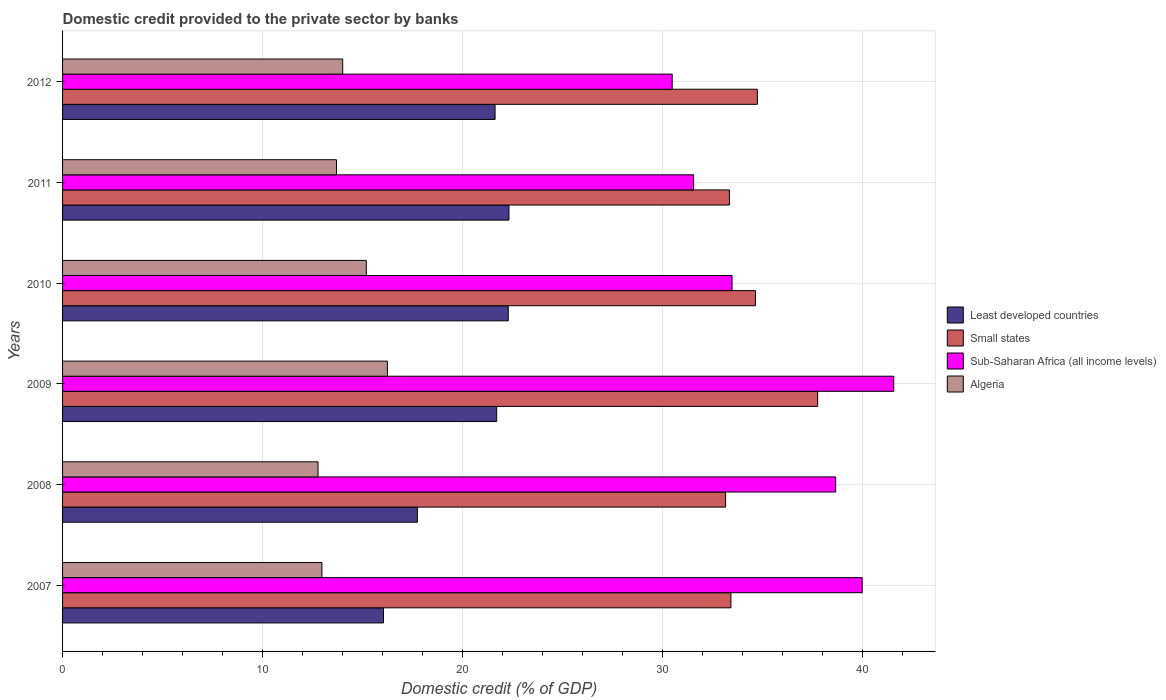How many groups of bars are there?
Offer a terse response. 6. Are the number of bars per tick equal to the number of legend labels?
Give a very brief answer. Yes. How many bars are there on the 6th tick from the top?
Make the answer very short. 4. How many bars are there on the 2nd tick from the bottom?
Keep it short and to the point. 4. In how many cases, is the number of bars for a given year not equal to the number of legend labels?
Provide a succinct answer. 0. What is the domestic credit provided to the private sector by banks in Small states in 2008?
Offer a terse response. 33.16. Across all years, what is the maximum domestic credit provided to the private sector by banks in Algeria?
Ensure brevity in your answer.  16.25. Across all years, what is the minimum domestic credit provided to the private sector by banks in Algeria?
Offer a terse response. 12.78. In which year was the domestic credit provided to the private sector by banks in Small states minimum?
Make the answer very short. 2008. What is the total domestic credit provided to the private sector by banks in Small states in the graph?
Keep it short and to the point. 207.1. What is the difference between the domestic credit provided to the private sector by banks in Sub-Saharan Africa (all income levels) in 2007 and that in 2008?
Provide a succinct answer. 1.32. What is the difference between the domestic credit provided to the private sector by banks in Algeria in 2011 and the domestic credit provided to the private sector by banks in Sub-Saharan Africa (all income levels) in 2007?
Make the answer very short. -26.29. What is the average domestic credit provided to the private sector by banks in Small states per year?
Offer a very short reply. 34.52. In the year 2011, what is the difference between the domestic credit provided to the private sector by banks in Algeria and domestic credit provided to the private sector by banks in Small states?
Provide a succinct answer. -19.65. What is the ratio of the domestic credit provided to the private sector by banks in Sub-Saharan Africa (all income levels) in 2009 to that in 2012?
Your response must be concise. 1.36. Is the domestic credit provided to the private sector by banks in Algeria in 2007 less than that in 2009?
Your response must be concise. Yes. Is the difference between the domestic credit provided to the private sector by banks in Algeria in 2008 and 2011 greater than the difference between the domestic credit provided to the private sector by banks in Small states in 2008 and 2011?
Provide a short and direct response. No. What is the difference between the highest and the second highest domestic credit provided to the private sector by banks in Least developed countries?
Ensure brevity in your answer.  0.03. What is the difference between the highest and the lowest domestic credit provided to the private sector by banks in Sub-Saharan Africa (all income levels)?
Your answer should be compact. 11.08. Is the sum of the domestic credit provided to the private sector by banks in Algeria in 2007 and 2010 greater than the maximum domestic credit provided to the private sector by banks in Sub-Saharan Africa (all income levels) across all years?
Keep it short and to the point. No. What does the 4th bar from the top in 2012 represents?
Offer a terse response. Least developed countries. What does the 1st bar from the bottom in 2009 represents?
Provide a short and direct response. Least developed countries. Is it the case that in every year, the sum of the domestic credit provided to the private sector by banks in Sub-Saharan Africa (all income levels) and domestic credit provided to the private sector by banks in Least developed countries is greater than the domestic credit provided to the private sector by banks in Small states?
Offer a very short reply. Yes. How many bars are there?
Offer a terse response. 24. Are all the bars in the graph horizontal?
Your response must be concise. Yes. How many years are there in the graph?
Your answer should be very brief. 6. Are the values on the major ticks of X-axis written in scientific E-notation?
Offer a terse response. No. Where does the legend appear in the graph?
Your answer should be very brief. Center right. What is the title of the graph?
Your answer should be compact. Domestic credit provided to the private sector by banks. What is the label or title of the X-axis?
Provide a succinct answer. Domestic credit (% of GDP). What is the Domestic credit (% of GDP) of Least developed countries in 2007?
Provide a succinct answer. 16.05. What is the Domestic credit (% of GDP) in Small states in 2007?
Give a very brief answer. 33.43. What is the Domestic credit (% of GDP) in Sub-Saharan Africa (all income levels) in 2007?
Ensure brevity in your answer.  39.99. What is the Domestic credit (% of GDP) in Algeria in 2007?
Your answer should be very brief. 12.97. What is the Domestic credit (% of GDP) in Least developed countries in 2008?
Your answer should be compact. 17.75. What is the Domestic credit (% of GDP) of Small states in 2008?
Your answer should be compact. 33.16. What is the Domestic credit (% of GDP) in Sub-Saharan Africa (all income levels) in 2008?
Offer a very short reply. 38.66. What is the Domestic credit (% of GDP) of Algeria in 2008?
Provide a short and direct response. 12.78. What is the Domestic credit (% of GDP) in Least developed countries in 2009?
Ensure brevity in your answer.  21.71. What is the Domestic credit (% of GDP) of Small states in 2009?
Give a very brief answer. 37.76. What is the Domestic credit (% of GDP) in Sub-Saharan Africa (all income levels) in 2009?
Offer a very short reply. 41.57. What is the Domestic credit (% of GDP) of Algeria in 2009?
Make the answer very short. 16.25. What is the Domestic credit (% of GDP) in Least developed countries in 2010?
Keep it short and to the point. 22.29. What is the Domestic credit (% of GDP) in Small states in 2010?
Provide a succinct answer. 34.65. What is the Domestic credit (% of GDP) in Sub-Saharan Africa (all income levels) in 2010?
Give a very brief answer. 33.48. What is the Domestic credit (% of GDP) of Algeria in 2010?
Offer a very short reply. 15.19. What is the Domestic credit (% of GDP) of Least developed countries in 2011?
Your answer should be very brief. 22.32. What is the Domestic credit (% of GDP) in Small states in 2011?
Give a very brief answer. 33.35. What is the Domestic credit (% of GDP) of Sub-Saharan Africa (all income levels) in 2011?
Provide a short and direct response. 31.56. What is the Domestic credit (% of GDP) of Algeria in 2011?
Your answer should be very brief. 13.7. What is the Domestic credit (% of GDP) in Least developed countries in 2012?
Make the answer very short. 21.63. What is the Domestic credit (% of GDP) of Small states in 2012?
Ensure brevity in your answer.  34.75. What is the Domestic credit (% of GDP) of Sub-Saharan Africa (all income levels) in 2012?
Provide a succinct answer. 30.49. What is the Domestic credit (% of GDP) of Algeria in 2012?
Provide a short and direct response. 14.01. Across all years, what is the maximum Domestic credit (% of GDP) of Least developed countries?
Offer a terse response. 22.32. Across all years, what is the maximum Domestic credit (% of GDP) in Small states?
Your answer should be compact. 37.76. Across all years, what is the maximum Domestic credit (% of GDP) of Sub-Saharan Africa (all income levels)?
Provide a short and direct response. 41.57. Across all years, what is the maximum Domestic credit (% of GDP) in Algeria?
Keep it short and to the point. 16.25. Across all years, what is the minimum Domestic credit (% of GDP) in Least developed countries?
Provide a succinct answer. 16.05. Across all years, what is the minimum Domestic credit (% of GDP) of Small states?
Provide a short and direct response. 33.16. Across all years, what is the minimum Domestic credit (% of GDP) in Sub-Saharan Africa (all income levels)?
Give a very brief answer. 30.49. Across all years, what is the minimum Domestic credit (% of GDP) in Algeria?
Your answer should be compact. 12.78. What is the total Domestic credit (% of GDP) of Least developed countries in the graph?
Ensure brevity in your answer.  121.75. What is the total Domestic credit (% of GDP) in Small states in the graph?
Provide a short and direct response. 207.1. What is the total Domestic credit (% of GDP) of Sub-Saharan Africa (all income levels) in the graph?
Provide a succinct answer. 215.75. What is the total Domestic credit (% of GDP) of Algeria in the graph?
Make the answer very short. 84.89. What is the difference between the Domestic credit (% of GDP) in Least developed countries in 2007 and that in 2008?
Your answer should be compact. -1.7. What is the difference between the Domestic credit (% of GDP) in Small states in 2007 and that in 2008?
Offer a very short reply. 0.27. What is the difference between the Domestic credit (% of GDP) in Sub-Saharan Africa (all income levels) in 2007 and that in 2008?
Ensure brevity in your answer.  1.32. What is the difference between the Domestic credit (% of GDP) of Algeria in 2007 and that in 2008?
Ensure brevity in your answer.  0.19. What is the difference between the Domestic credit (% of GDP) of Least developed countries in 2007 and that in 2009?
Your response must be concise. -5.66. What is the difference between the Domestic credit (% of GDP) of Small states in 2007 and that in 2009?
Provide a succinct answer. -4.34. What is the difference between the Domestic credit (% of GDP) in Sub-Saharan Africa (all income levels) in 2007 and that in 2009?
Your response must be concise. -1.58. What is the difference between the Domestic credit (% of GDP) of Algeria in 2007 and that in 2009?
Provide a succinct answer. -3.28. What is the difference between the Domestic credit (% of GDP) in Least developed countries in 2007 and that in 2010?
Give a very brief answer. -6.24. What is the difference between the Domestic credit (% of GDP) in Small states in 2007 and that in 2010?
Offer a terse response. -1.23. What is the difference between the Domestic credit (% of GDP) in Sub-Saharan Africa (all income levels) in 2007 and that in 2010?
Your answer should be compact. 6.51. What is the difference between the Domestic credit (% of GDP) of Algeria in 2007 and that in 2010?
Make the answer very short. -2.22. What is the difference between the Domestic credit (% of GDP) of Least developed countries in 2007 and that in 2011?
Give a very brief answer. -6.27. What is the difference between the Domestic credit (% of GDP) of Small states in 2007 and that in 2011?
Provide a succinct answer. 0.08. What is the difference between the Domestic credit (% of GDP) in Sub-Saharan Africa (all income levels) in 2007 and that in 2011?
Offer a very short reply. 8.43. What is the difference between the Domestic credit (% of GDP) of Algeria in 2007 and that in 2011?
Give a very brief answer. -0.73. What is the difference between the Domestic credit (% of GDP) in Least developed countries in 2007 and that in 2012?
Offer a terse response. -5.58. What is the difference between the Domestic credit (% of GDP) of Small states in 2007 and that in 2012?
Ensure brevity in your answer.  -1.32. What is the difference between the Domestic credit (% of GDP) in Sub-Saharan Africa (all income levels) in 2007 and that in 2012?
Provide a short and direct response. 9.5. What is the difference between the Domestic credit (% of GDP) of Algeria in 2007 and that in 2012?
Your answer should be compact. -1.04. What is the difference between the Domestic credit (% of GDP) in Least developed countries in 2008 and that in 2009?
Your answer should be very brief. -3.96. What is the difference between the Domestic credit (% of GDP) of Small states in 2008 and that in 2009?
Your response must be concise. -4.6. What is the difference between the Domestic credit (% of GDP) of Sub-Saharan Africa (all income levels) in 2008 and that in 2009?
Offer a very short reply. -2.9. What is the difference between the Domestic credit (% of GDP) in Algeria in 2008 and that in 2009?
Offer a terse response. -3.47. What is the difference between the Domestic credit (% of GDP) in Least developed countries in 2008 and that in 2010?
Give a very brief answer. -4.54. What is the difference between the Domestic credit (% of GDP) of Small states in 2008 and that in 2010?
Your answer should be very brief. -1.49. What is the difference between the Domestic credit (% of GDP) in Sub-Saharan Africa (all income levels) in 2008 and that in 2010?
Make the answer very short. 5.18. What is the difference between the Domestic credit (% of GDP) of Algeria in 2008 and that in 2010?
Provide a succinct answer. -2.41. What is the difference between the Domestic credit (% of GDP) in Least developed countries in 2008 and that in 2011?
Keep it short and to the point. -4.58. What is the difference between the Domestic credit (% of GDP) in Small states in 2008 and that in 2011?
Make the answer very short. -0.19. What is the difference between the Domestic credit (% of GDP) in Sub-Saharan Africa (all income levels) in 2008 and that in 2011?
Provide a short and direct response. 7.11. What is the difference between the Domestic credit (% of GDP) in Algeria in 2008 and that in 2011?
Provide a succinct answer. -0.92. What is the difference between the Domestic credit (% of GDP) in Least developed countries in 2008 and that in 2012?
Offer a terse response. -3.88. What is the difference between the Domestic credit (% of GDP) in Small states in 2008 and that in 2012?
Provide a succinct answer. -1.59. What is the difference between the Domestic credit (% of GDP) of Sub-Saharan Africa (all income levels) in 2008 and that in 2012?
Offer a very short reply. 8.18. What is the difference between the Domestic credit (% of GDP) in Algeria in 2008 and that in 2012?
Your answer should be very brief. -1.23. What is the difference between the Domestic credit (% of GDP) of Least developed countries in 2009 and that in 2010?
Give a very brief answer. -0.58. What is the difference between the Domestic credit (% of GDP) of Small states in 2009 and that in 2010?
Offer a very short reply. 3.11. What is the difference between the Domestic credit (% of GDP) of Sub-Saharan Africa (all income levels) in 2009 and that in 2010?
Ensure brevity in your answer.  8.09. What is the difference between the Domestic credit (% of GDP) of Algeria in 2009 and that in 2010?
Your response must be concise. 1.05. What is the difference between the Domestic credit (% of GDP) in Least developed countries in 2009 and that in 2011?
Keep it short and to the point. -0.61. What is the difference between the Domestic credit (% of GDP) in Small states in 2009 and that in 2011?
Make the answer very short. 4.41. What is the difference between the Domestic credit (% of GDP) in Sub-Saharan Africa (all income levels) in 2009 and that in 2011?
Offer a very short reply. 10.01. What is the difference between the Domestic credit (% of GDP) of Algeria in 2009 and that in 2011?
Give a very brief answer. 2.55. What is the difference between the Domestic credit (% of GDP) of Least developed countries in 2009 and that in 2012?
Keep it short and to the point. 0.08. What is the difference between the Domestic credit (% of GDP) in Small states in 2009 and that in 2012?
Ensure brevity in your answer.  3.01. What is the difference between the Domestic credit (% of GDP) in Sub-Saharan Africa (all income levels) in 2009 and that in 2012?
Offer a terse response. 11.08. What is the difference between the Domestic credit (% of GDP) in Algeria in 2009 and that in 2012?
Your answer should be very brief. 2.24. What is the difference between the Domestic credit (% of GDP) of Least developed countries in 2010 and that in 2011?
Offer a very short reply. -0.03. What is the difference between the Domestic credit (% of GDP) in Small states in 2010 and that in 2011?
Your answer should be compact. 1.3. What is the difference between the Domestic credit (% of GDP) in Sub-Saharan Africa (all income levels) in 2010 and that in 2011?
Your answer should be very brief. 1.92. What is the difference between the Domestic credit (% of GDP) in Algeria in 2010 and that in 2011?
Keep it short and to the point. 1.49. What is the difference between the Domestic credit (% of GDP) of Least developed countries in 2010 and that in 2012?
Make the answer very short. 0.66. What is the difference between the Domestic credit (% of GDP) of Small states in 2010 and that in 2012?
Provide a short and direct response. -0.1. What is the difference between the Domestic credit (% of GDP) of Sub-Saharan Africa (all income levels) in 2010 and that in 2012?
Make the answer very short. 2.99. What is the difference between the Domestic credit (% of GDP) of Algeria in 2010 and that in 2012?
Provide a succinct answer. 1.18. What is the difference between the Domestic credit (% of GDP) of Least developed countries in 2011 and that in 2012?
Your response must be concise. 0.69. What is the difference between the Domestic credit (% of GDP) of Small states in 2011 and that in 2012?
Your answer should be compact. -1.4. What is the difference between the Domestic credit (% of GDP) of Sub-Saharan Africa (all income levels) in 2011 and that in 2012?
Make the answer very short. 1.07. What is the difference between the Domestic credit (% of GDP) in Algeria in 2011 and that in 2012?
Provide a succinct answer. -0.31. What is the difference between the Domestic credit (% of GDP) of Least developed countries in 2007 and the Domestic credit (% of GDP) of Small states in 2008?
Keep it short and to the point. -17.11. What is the difference between the Domestic credit (% of GDP) in Least developed countries in 2007 and the Domestic credit (% of GDP) in Sub-Saharan Africa (all income levels) in 2008?
Offer a very short reply. -22.61. What is the difference between the Domestic credit (% of GDP) of Least developed countries in 2007 and the Domestic credit (% of GDP) of Algeria in 2008?
Keep it short and to the point. 3.27. What is the difference between the Domestic credit (% of GDP) in Small states in 2007 and the Domestic credit (% of GDP) in Sub-Saharan Africa (all income levels) in 2008?
Provide a short and direct response. -5.24. What is the difference between the Domestic credit (% of GDP) of Small states in 2007 and the Domestic credit (% of GDP) of Algeria in 2008?
Your answer should be very brief. 20.65. What is the difference between the Domestic credit (% of GDP) in Sub-Saharan Africa (all income levels) in 2007 and the Domestic credit (% of GDP) in Algeria in 2008?
Your response must be concise. 27.21. What is the difference between the Domestic credit (% of GDP) in Least developed countries in 2007 and the Domestic credit (% of GDP) in Small states in 2009?
Your answer should be very brief. -21.71. What is the difference between the Domestic credit (% of GDP) in Least developed countries in 2007 and the Domestic credit (% of GDP) in Sub-Saharan Africa (all income levels) in 2009?
Make the answer very short. -25.52. What is the difference between the Domestic credit (% of GDP) in Least developed countries in 2007 and the Domestic credit (% of GDP) in Algeria in 2009?
Offer a terse response. -0.19. What is the difference between the Domestic credit (% of GDP) of Small states in 2007 and the Domestic credit (% of GDP) of Sub-Saharan Africa (all income levels) in 2009?
Provide a short and direct response. -8.14. What is the difference between the Domestic credit (% of GDP) in Small states in 2007 and the Domestic credit (% of GDP) in Algeria in 2009?
Keep it short and to the point. 17.18. What is the difference between the Domestic credit (% of GDP) in Sub-Saharan Africa (all income levels) in 2007 and the Domestic credit (% of GDP) in Algeria in 2009?
Offer a very short reply. 23.74. What is the difference between the Domestic credit (% of GDP) of Least developed countries in 2007 and the Domestic credit (% of GDP) of Small states in 2010?
Provide a short and direct response. -18.6. What is the difference between the Domestic credit (% of GDP) of Least developed countries in 2007 and the Domestic credit (% of GDP) of Sub-Saharan Africa (all income levels) in 2010?
Give a very brief answer. -17.43. What is the difference between the Domestic credit (% of GDP) of Least developed countries in 2007 and the Domestic credit (% of GDP) of Algeria in 2010?
Ensure brevity in your answer.  0.86. What is the difference between the Domestic credit (% of GDP) of Small states in 2007 and the Domestic credit (% of GDP) of Sub-Saharan Africa (all income levels) in 2010?
Offer a very short reply. -0.06. What is the difference between the Domestic credit (% of GDP) in Small states in 2007 and the Domestic credit (% of GDP) in Algeria in 2010?
Give a very brief answer. 18.24. What is the difference between the Domestic credit (% of GDP) in Sub-Saharan Africa (all income levels) in 2007 and the Domestic credit (% of GDP) in Algeria in 2010?
Offer a very short reply. 24.8. What is the difference between the Domestic credit (% of GDP) in Least developed countries in 2007 and the Domestic credit (% of GDP) in Small states in 2011?
Ensure brevity in your answer.  -17.3. What is the difference between the Domestic credit (% of GDP) of Least developed countries in 2007 and the Domestic credit (% of GDP) of Sub-Saharan Africa (all income levels) in 2011?
Your answer should be compact. -15.51. What is the difference between the Domestic credit (% of GDP) of Least developed countries in 2007 and the Domestic credit (% of GDP) of Algeria in 2011?
Offer a terse response. 2.35. What is the difference between the Domestic credit (% of GDP) in Small states in 2007 and the Domestic credit (% of GDP) in Sub-Saharan Africa (all income levels) in 2011?
Make the answer very short. 1.87. What is the difference between the Domestic credit (% of GDP) of Small states in 2007 and the Domestic credit (% of GDP) of Algeria in 2011?
Make the answer very short. 19.73. What is the difference between the Domestic credit (% of GDP) in Sub-Saharan Africa (all income levels) in 2007 and the Domestic credit (% of GDP) in Algeria in 2011?
Give a very brief answer. 26.29. What is the difference between the Domestic credit (% of GDP) in Least developed countries in 2007 and the Domestic credit (% of GDP) in Small states in 2012?
Make the answer very short. -18.7. What is the difference between the Domestic credit (% of GDP) in Least developed countries in 2007 and the Domestic credit (% of GDP) in Sub-Saharan Africa (all income levels) in 2012?
Provide a succinct answer. -14.44. What is the difference between the Domestic credit (% of GDP) in Least developed countries in 2007 and the Domestic credit (% of GDP) in Algeria in 2012?
Offer a terse response. 2.04. What is the difference between the Domestic credit (% of GDP) of Small states in 2007 and the Domestic credit (% of GDP) of Sub-Saharan Africa (all income levels) in 2012?
Keep it short and to the point. 2.94. What is the difference between the Domestic credit (% of GDP) in Small states in 2007 and the Domestic credit (% of GDP) in Algeria in 2012?
Your answer should be compact. 19.42. What is the difference between the Domestic credit (% of GDP) in Sub-Saharan Africa (all income levels) in 2007 and the Domestic credit (% of GDP) in Algeria in 2012?
Provide a short and direct response. 25.98. What is the difference between the Domestic credit (% of GDP) of Least developed countries in 2008 and the Domestic credit (% of GDP) of Small states in 2009?
Ensure brevity in your answer.  -20.02. What is the difference between the Domestic credit (% of GDP) in Least developed countries in 2008 and the Domestic credit (% of GDP) in Sub-Saharan Africa (all income levels) in 2009?
Your answer should be very brief. -23.82. What is the difference between the Domestic credit (% of GDP) in Least developed countries in 2008 and the Domestic credit (% of GDP) in Algeria in 2009?
Make the answer very short. 1.5. What is the difference between the Domestic credit (% of GDP) in Small states in 2008 and the Domestic credit (% of GDP) in Sub-Saharan Africa (all income levels) in 2009?
Offer a terse response. -8.41. What is the difference between the Domestic credit (% of GDP) in Small states in 2008 and the Domestic credit (% of GDP) in Algeria in 2009?
Give a very brief answer. 16.91. What is the difference between the Domestic credit (% of GDP) of Sub-Saharan Africa (all income levels) in 2008 and the Domestic credit (% of GDP) of Algeria in 2009?
Make the answer very short. 22.42. What is the difference between the Domestic credit (% of GDP) in Least developed countries in 2008 and the Domestic credit (% of GDP) in Small states in 2010?
Give a very brief answer. -16.91. What is the difference between the Domestic credit (% of GDP) in Least developed countries in 2008 and the Domestic credit (% of GDP) in Sub-Saharan Africa (all income levels) in 2010?
Provide a succinct answer. -15.74. What is the difference between the Domestic credit (% of GDP) in Least developed countries in 2008 and the Domestic credit (% of GDP) in Algeria in 2010?
Give a very brief answer. 2.55. What is the difference between the Domestic credit (% of GDP) in Small states in 2008 and the Domestic credit (% of GDP) in Sub-Saharan Africa (all income levels) in 2010?
Offer a very short reply. -0.32. What is the difference between the Domestic credit (% of GDP) of Small states in 2008 and the Domestic credit (% of GDP) of Algeria in 2010?
Ensure brevity in your answer.  17.97. What is the difference between the Domestic credit (% of GDP) of Sub-Saharan Africa (all income levels) in 2008 and the Domestic credit (% of GDP) of Algeria in 2010?
Ensure brevity in your answer.  23.47. What is the difference between the Domestic credit (% of GDP) of Least developed countries in 2008 and the Domestic credit (% of GDP) of Small states in 2011?
Offer a terse response. -15.6. What is the difference between the Domestic credit (% of GDP) in Least developed countries in 2008 and the Domestic credit (% of GDP) in Sub-Saharan Africa (all income levels) in 2011?
Offer a very short reply. -13.81. What is the difference between the Domestic credit (% of GDP) in Least developed countries in 2008 and the Domestic credit (% of GDP) in Algeria in 2011?
Keep it short and to the point. 4.05. What is the difference between the Domestic credit (% of GDP) of Small states in 2008 and the Domestic credit (% of GDP) of Sub-Saharan Africa (all income levels) in 2011?
Make the answer very short. 1.6. What is the difference between the Domestic credit (% of GDP) in Small states in 2008 and the Domestic credit (% of GDP) in Algeria in 2011?
Offer a very short reply. 19.46. What is the difference between the Domestic credit (% of GDP) of Sub-Saharan Africa (all income levels) in 2008 and the Domestic credit (% of GDP) of Algeria in 2011?
Ensure brevity in your answer.  24.97. What is the difference between the Domestic credit (% of GDP) of Least developed countries in 2008 and the Domestic credit (% of GDP) of Small states in 2012?
Your answer should be very brief. -17. What is the difference between the Domestic credit (% of GDP) in Least developed countries in 2008 and the Domestic credit (% of GDP) in Sub-Saharan Africa (all income levels) in 2012?
Make the answer very short. -12.74. What is the difference between the Domestic credit (% of GDP) of Least developed countries in 2008 and the Domestic credit (% of GDP) of Algeria in 2012?
Your answer should be compact. 3.74. What is the difference between the Domestic credit (% of GDP) of Small states in 2008 and the Domestic credit (% of GDP) of Sub-Saharan Africa (all income levels) in 2012?
Your answer should be very brief. 2.67. What is the difference between the Domestic credit (% of GDP) in Small states in 2008 and the Domestic credit (% of GDP) in Algeria in 2012?
Provide a succinct answer. 19.15. What is the difference between the Domestic credit (% of GDP) of Sub-Saharan Africa (all income levels) in 2008 and the Domestic credit (% of GDP) of Algeria in 2012?
Keep it short and to the point. 24.66. What is the difference between the Domestic credit (% of GDP) of Least developed countries in 2009 and the Domestic credit (% of GDP) of Small states in 2010?
Offer a terse response. -12.94. What is the difference between the Domestic credit (% of GDP) of Least developed countries in 2009 and the Domestic credit (% of GDP) of Sub-Saharan Africa (all income levels) in 2010?
Keep it short and to the point. -11.77. What is the difference between the Domestic credit (% of GDP) of Least developed countries in 2009 and the Domestic credit (% of GDP) of Algeria in 2010?
Your answer should be very brief. 6.52. What is the difference between the Domestic credit (% of GDP) in Small states in 2009 and the Domestic credit (% of GDP) in Sub-Saharan Africa (all income levels) in 2010?
Your response must be concise. 4.28. What is the difference between the Domestic credit (% of GDP) in Small states in 2009 and the Domestic credit (% of GDP) in Algeria in 2010?
Give a very brief answer. 22.57. What is the difference between the Domestic credit (% of GDP) in Sub-Saharan Africa (all income levels) in 2009 and the Domestic credit (% of GDP) in Algeria in 2010?
Give a very brief answer. 26.38. What is the difference between the Domestic credit (% of GDP) in Least developed countries in 2009 and the Domestic credit (% of GDP) in Small states in 2011?
Your answer should be very brief. -11.64. What is the difference between the Domestic credit (% of GDP) in Least developed countries in 2009 and the Domestic credit (% of GDP) in Sub-Saharan Africa (all income levels) in 2011?
Offer a very short reply. -9.85. What is the difference between the Domestic credit (% of GDP) of Least developed countries in 2009 and the Domestic credit (% of GDP) of Algeria in 2011?
Offer a terse response. 8.01. What is the difference between the Domestic credit (% of GDP) in Small states in 2009 and the Domestic credit (% of GDP) in Sub-Saharan Africa (all income levels) in 2011?
Ensure brevity in your answer.  6.2. What is the difference between the Domestic credit (% of GDP) in Small states in 2009 and the Domestic credit (% of GDP) in Algeria in 2011?
Your response must be concise. 24.06. What is the difference between the Domestic credit (% of GDP) in Sub-Saharan Africa (all income levels) in 2009 and the Domestic credit (% of GDP) in Algeria in 2011?
Provide a succinct answer. 27.87. What is the difference between the Domestic credit (% of GDP) in Least developed countries in 2009 and the Domestic credit (% of GDP) in Small states in 2012?
Your response must be concise. -13.04. What is the difference between the Domestic credit (% of GDP) of Least developed countries in 2009 and the Domestic credit (% of GDP) of Sub-Saharan Africa (all income levels) in 2012?
Provide a short and direct response. -8.78. What is the difference between the Domestic credit (% of GDP) of Least developed countries in 2009 and the Domestic credit (% of GDP) of Algeria in 2012?
Provide a succinct answer. 7.7. What is the difference between the Domestic credit (% of GDP) in Small states in 2009 and the Domestic credit (% of GDP) in Sub-Saharan Africa (all income levels) in 2012?
Your answer should be very brief. 7.27. What is the difference between the Domestic credit (% of GDP) in Small states in 2009 and the Domestic credit (% of GDP) in Algeria in 2012?
Your response must be concise. 23.75. What is the difference between the Domestic credit (% of GDP) of Sub-Saharan Africa (all income levels) in 2009 and the Domestic credit (% of GDP) of Algeria in 2012?
Offer a terse response. 27.56. What is the difference between the Domestic credit (% of GDP) of Least developed countries in 2010 and the Domestic credit (% of GDP) of Small states in 2011?
Provide a short and direct response. -11.06. What is the difference between the Domestic credit (% of GDP) in Least developed countries in 2010 and the Domestic credit (% of GDP) in Sub-Saharan Africa (all income levels) in 2011?
Make the answer very short. -9.27. What is the difference between the Domestic credit (% of GDP) of Least developed countries in 2010 and the Domestic credit (% of GDP) of Algeria in 2011?
Give a very brief answer. 8.59. What is the difference between the Domestic credit (% of GDP) in Small states in 2010 and the Domestic credit (% of GDP) in Sub-Saharan Africa (all income levels) in 2011?
Offer a very short reply. 3.09. What is the difference between the Domestic credit (% of GDP) in Small states in 2010 and the Domestic credit (% of GDP) in Algeria in 2011?
Your response must be concise. 20.95. What is the difference between the Domestic credit (% of GDP) of Sub-Saharan Africa (all income levels) in 2010 and the Domestic credit (% of GDP) of Algeria in 2011?
Offer a very short reply. 19.78. What is the difference between the Domestic credit (% of GDP) in Least developed countries in 2010 and the Domestic credit (% of GDP) in Small states in 2012?
Your answer should be very brief. -12.46. What is the difference between the Domestic credit (% of GDP) of Least developed countries in 2010 and the Domestic credit (% of GDP) of Sub-Saharan Africa (all income levels) in 2012?
Your answer should be very brief. -8.2. What is the difference between the Domestic credit (% of GDP) in Least developed countries in 2010 and the Domestic credit (% of GDP) in Algeria in 2012?
Make the answer very short. 8.28. What is the difference between the Domestic credit (% of GDP) in Small states in 2010 and the Domestic credit (% of GDP) in Sub-Saharan Africa (all income levels) in 2012?
Give a very brief answer. 4.16. What is the difference between the Domestic credit (% of GDP) of Small states in 2010 and the Domestic credit (% of GDP) of Algeria in 2012?
Your response must be concise. 20.64. What is the difference between the Domestic credit (% of GDP) in Sub-Saharan Africa (all income levels) in 2010 and the Domestic credit (% of GDP) in Algeria in 2012?
Make the answer very short. 19.47. What is the difference between the Domestic credit (% of GDP) of Least developed countries in 2011 and the Domestic credit (% of GDP) of Small states in 2012?
Provide a short and direct response. -12.42. What is the difference between the Domestic credit (% of GDP) of Least developed countries in 2011 and the Domestic credit (% of GDP) of Sub-Saharan Africa (all income levels) in 2012?
Give a very brief answer. -8.16. What is the difference between the Domestic credit (% of GDP) of Least developed countries in 2011 and the Domestic credit (% of GDP) of Algeria in 2012?
Make the answer very short. 8.31. What is the difference between the Domestic credit (% of GDP) of Small states in 2011 and the Domestic credit (% of GDP) of Sub-Saharan Africa (all income levels) in 2012?
Offer a very short reply. 2.86. What is the difference between the Domestic credit (% of GDP) in Small states in 2011 and the Domestic credit (% of GDP) in Algeria in 2012?
Give a very brief answer. 19.34. What is the difference between the Domestic credit (% of GDP) in Sub-Saharan Africa (all income levels) in 2011 and the Domestic credit (% of GDP) in Algeria in 2012?
Your answer should be very brief. 17.55. What is the average Domestic credit (% of GDP) in Least developed countries per year?
Keep it short and to the point. 20.29. What is the average Domestic credit (% of GDP) of Small states per year?
Ensure brevity in your answer.  34.52. What is the average Domestic credit (% of GDP) of Sub-Saharan Africa (all income levels) per year?
Keep it short and to the point. 35.96. What is the average Domestic credit (% of GDP) in Algeria per year?
Provide a short and direct response. 14.15. In the year 2007, what is the difference between the Domestic credit (% of GDP) in Least developed countries and Domestic credit (% of GDP) in Small states?
Your answer should be compact. -17.38. In the year 2007, what is the difference between the Domestic credit (% of GDP) in Least developed countries and Domestic credit (% of GDP) in Sub-Saharan Africa (all income levels)?
Make the answer very short. -23.94. In the year 2007, what is the difference between the Domestic credit (% of GDP) in Least developed countries and Domestic credit (% of GDP) in Algeria?
Offer a very short reply. 3.08. In the year 2007, what is the difference between the Domestic credit (% of GDP) of Small states and Domestic credit (% of GDP) of Sub-Saharan Africa (all income levels)?
Keep it short and to the point. -6.56. In the year 2007, what is the difference between the Domestic credit (% of GDP) of Small states and Domestic credit (% of GDP) of Algeria?
Provide a short and direct response. 20.46. In the year 2007, what is the difference between the Domestic credit (% of GDP) in Sub-Saharan Africa (all income levels) and Domestic credit (% of GDP) in Algeria?
Give a very brief answer. 27.02. In the year 2008, what is the difference between the Domestic credit (% of GDP) of Least developed countries and Domestic credit (% of GDP) of Small states?
Make the answer very short. -15.41. In the year 2008, what is the difference between the Domestic credit (% of GDP) of Least developed countries and Domestic credit (% of GDP) of Sub-Saharan Africa (all income levels)?
Offer a very short reply. -20.92. In the year 2008, what is the difference between the Domestic credit (% of GDP) of Least developed countries and Domestic credit (% of GDP) of Algeria?
Your answer should be very brief. 4.97. In the year 2008, what is the difference between the Domestic credit (% of GDP) of Small states and Domestic credit (% of GDP) of Sub-Saharan Africa (all income levels)?
Ensure brevity in your answer.  -5.51. In the year 2008, what is the difference between the Domestic credit (% of GDP) in Small states and Domestic credit (% of GDP) in Algeria?
Your answer should be very brief. 20.38. In the year 2008, what is the difference between the Domestic credit (% of GDP) of Sub-Saharan Africa (all income levels) and Domestic credit (% of GDP) of Algeria?
Give a very brief answer. 25.89. In the year 2009, what is the difference between the Domestic credit (% of GDP) in Least developed countries and Domestic credit (% of GDP) in Small states?
Ensure brevity in your answer.  -16.05. In the year 2009, what is the difference between the Domestic credit (% of GDP) in Least developed countries and Domestic credit (% of GDP) in Sub-Saharan Africa (all income levels)?
Offer a very short reply. -19.86. In the year 2009, what is the difference between the Domestic credit (% of GDP) of Least developed countries and Domestic credit (% of GDP) of Algeria?
Your answer should be compact. 5.47. In the year 2009, what is the difference between the Domestic credit (% of GDP) of Small states and Domestic credit (% of GDP) of Sub-Saharan Africa (all income levels)?
Offer a very short reply. -3.81. In the year 2009, what is the difference between the Domestic credit (% of GDP) of Small states and Domestic credit (% of GDP) of Algeria?
Your response must be concise. 21.52. In the year 2009, what is the difference between the Domestic credit (% of GDP) of Sub-Saharan Africa (all income levels) and Domestic credit (% of GDP) of Algeria?
Provide a short and direct response. 25.32. In the year 2010, what is the difference between the Domestic credit (% of GDP) in Least developed countries and Domestic credit (% of GDP) in Small states?
Give a very brief answer. -12.36. In the year 2010, what is the difference between the Domestic credit (% of GDP) in Least developed countries and Domestic credit (% of GDP) in Sub-Saharan Africa (all income levels)?
Offer a terse response. -11.19. In the year 2010, what is the difference between the Domestic credit (% of GDP) in Least developed countries and Domestic credit (% of GDP) in Algeria?
Offer a very short reply. 7.1. In the year 2010, what is the difference between the Domestic credit (% of GDP) of Small states and Domestic credit (% of GDP) of Sub-Saharan Africa (all income levels)?
Your answer should be compact. 1.17. In the year 2010, what is the difference between the Domestic credit (% of GDP) of Small states and Domestic credit (% of GDP) of Algeria?
Make the answer very short. 19.46. In the year 2010, what is the difference between the Domestic credit (% of GDP) in Sub-Saharan Africa (all income levels) and Domestic credit (% of GDP) in Algeria?
Your answer should be compact. 18.29. In the year 2011, what is the difference between the Domestic credit (% of GDP) of Least developed countries and Domestic credit (% of GDP) of Small states?
Ensure brevity in your answer.  -11.02. In the year 2011, what is the difference between the Domestic credit (% of GDP) in Least developed countries and Domestic credit (% of GDP) in Sub-Saharan Africa (all income levels)?
Give a very brief answer. -9.23. In the year 2011, what is the difference between the Domestic credit (% of GDP) of Least developed countries and Domestic credit (% of GDP) of Algeria?
Your response must be concise. 8.63. In the year 2011, what is the difference between the Domestic credit (% of GDP) of Small states and Domestic credit (% of GDP) of Sub-Saharan Africa (all income levels)?
Ensure brevity in your answer.  1.79. In the year 2011, what is the difference between the Domestic credit (% of GDP) of Small states and Domestic credit (% of GDP) of Algeria?
Ensure brevity in your answer.  19.65. In the year 2011, what is the difference between the Domestic credit (% of GDP) in Sub-Saharan Africa (all income levels) and Domestic credit (% of GDP) in Algeria?
Your answer should be compact. 17.86. In the year 2012, what is the difference between the Domestic credit (% of GDP) of Least developed countries and Domestic credit (% of GDP) of Small states?
Make the answer very short. -13.12. In the year 2012, what is the difference between the Domestic credit (% of GDP) of Least developed countries and Domestic credit (% of GDP) of Sub-Saharan Africa (all income levels)?
Your response must be concise. -8.86. In the year 2012, what is the difference between the Domestic credit (% of GDP) in Least developed countries and Domestic credit (% of GDP) in Algeria?
Offer a terse response. 7.62. In the year 2012, what is the difference between the Domestic credit (% of GDP) in Small states and Domestic credit (% of GDP) in Sub-Saharan Africa (all income levels)?
Your answer should be very brief. 4.26. In the year 2012, what is the difference between the Domestic credit (% of GDP) of Small states and Domestic credit (% of GDP) of Algeria?
Offer a terse response. 20.74. In the year 2012, what is the difference between the Domestic credit (% of GDP) in Sub-Saharan Africa (all income levels) and Domestic credit (% of GDP) in Algeria?
Your answer should be very brief. 16.48. What is the ratio of the Domestic credit (% of GDP) of Least developed countries in 2007 to that in 2008?
Your answer should be compact. 0.9. What is the ratio of the Domestic credit (% of GDP) in Small states in 2007 to that in 2008?
Your answer should be very brief. 1.01. What is the ratio of the Domestic credit (% of GDP) in Sub-Saharan Africa (all income levels) in 2007 to that in 2008?
Your response must be concise. 1.03. What is the ratio of the Domestic credit (% of GDP) in Algeria in 2007 to that in 2008?
Give a very brief answer. 1.01. What is the ratio of the Domestic credit (% of GDP) in Least developed countries in 2007 to that in 2009?
Provide a succinct answer. 0.74. What is the ratio of the Domestic credit (% of GDP) in Small states in 2007 to that in 2009?
Offer a very short reply. 0.89. What is the ratio of the Domestic credit (% of GDP) in Sub-Saharan Africa (all income levels) in 2007 to that in 2009?
Provide a short and direct response. 0.96. What is the ratio of the Domestic credit (% of GDP) of Algeria in 2007 to that in 2009?
Provide a short and direct response. 0.8. What is the ratio of the Domestic credit (% of GDP) in Least developed countries in 2007 to that in 2010?
Provide a succinct answer. 0.72. What is the ratio of the Domestic credit (% of GDP) in Small states in 2007 to that in 2010?
Your answer should be very brief. 0.96. What is the ratio of the Domestic credit (% of GDP) of Sub-Saharan Africa (all income levels) in 2007 to that in 2010?
Your answer should be very brief. 1.19. What is the ratio of the Domestic credit (% of GDP) in Algeria in 2007 to that in 2010?
Provide a succinct answer. 0.85. What is the ratio of the Domestic credit (% of GDP) of Least developed countries in 2007 to that in 2011?
Ensure brevity in your answer.  0.72. What is the ratio of the Domestic credit (% of GDP) in Sub-Saharan Africa (all income levels) in 2007 to that in 2011?
Offer a very short reply. 1.27. What is the ratio of the Domestic credit (% of GDP) in Algeria in 2007 to that in 2011?
Offer a terse response. 0.95. What is the ratio of the Domestic credit (% of GDP) of Least developed countries in 2007 to that in 2012?
Offer a very short reply. 0.74. What is the ratio of the Domestic credit (% of GDP) in Small states in 2007 to that in 2012?
Provide a short and direct response. 0.96. What is the ratio of the Domestic credit (% of GDP) of Sub-Saharan Africa (all income levels) in 2007 to that in 2012?
Provide a short and direct response. 1.31. What is the ratio of the Domestic credit (% of GDP) in Algeria in 2007 to that in 2012?
Offer a very short reply. 0.93. What is the ratio of the Domestic credit (% of GDP) in Least developed countries in 2008 to that in 2009?
Give a very brief answer. 0.82. What is the ratio of the Domestic credit (% of GDP) in Small states in 2008 to that in 2009?
Your answer should be very brief. 0.88. What is the ratio of the Domestic credit (% of GDP) of Sub-Saharan Africa (all income levels) in 2008 to that in 2009?
Provide a succinct answer. 0.93. What is the ratio of the Domestic credit (% of GDP) in Algeria in 2008 to that in 2009?
Offer a terse response. 0.79. What is the ratio of the Domestic credit (% of GDP) of Least developed countries in 2008 to that in 2010?
Provide a succinct answer. 0.8. What is the ratio of the Domestic credit (% of GDP) in Small states in 2008 to that in 2010?
Keep it short and to the point. 0.96. What is the ratio of the Domestic credit (% of GDP) of Sub-Saharan Africa (all income levels) in 2008 to that in 2010?
Give a very brief answer. 1.15. What is the ratio of the Domestic credit (% of GDP) of Algeria in 2008 to that in 2010?
Your response must be concise. 0.84. What is the ratio of the Domestic credit (% of GDP) of Least developed countries in 2008 to that in 2011?
Give a very brief answer. 0.79. What is the ratio of the Domestic credit (% of GDP) of Small states in 2008 to that in 2011?
Your answer should be compact. 0.99. What is the ratio of the Domestic credit (% of GDP) in Sub-Saharan Africa (all income levels) in 2008 to that in 2011?
Make the answer very short. 1.23. What is the ratio of the Domestic credit (% of GDP) of Algeria in 2008 to that in 2011?
Offer a terse response. 0.93. What is the ratio of the Domestic credit (% of GDP) in Least developed countries in 2008 to that in 2012?
Your answer should be very brief. 0.82. What is the ratio of the Domestic credit (% of GDP) in Small states in 2008 to that in 2012?
Give a very brief answer. 0.95. What is the ratio of the Domestic credit (% of GDP) in Sub-Saharan Africa (all income levels) in 2008 to that in 2012?
Your answer should be compact. 1.27. What is the ratio of the Domestic credit (% of GDP) in Algeria in 2008 to that in 2012?
Ensure brevity in your answer.  0.91. What is the ratio of the Domestic credit (% of GDP) of Small states in 2009 to that in 2010?
Offer a terse response. 1.09. What is the ratio of the Domestic credit (% of GDP) of Sub-Saharan Africa (all income levels) in 2009 to that in 2010?
Make the answer very short. 1.24. What is the ratio of the Domestic credit (% of GDP) of Algeria in 2009 to that in 2010?
Your response must be concise. 1.07. What is the ratio of the Domestic credit (% of GDP) of Least developed countries in 2009 to that in 2011?
Keep it short and to the point. 0.97. What is the ratio of the Domestic credit (% of GDP) of Small states in 2009 to that in 2011?
Give a very brief answer. 1.13. What is the ratio of the Domestic credit (% of GDP) of Sub-Saharan Africa (all income levels) in 2009 to that in 2011?
Make the answer very short. 1.32. What is the ratio of the Domestic credit (% of GDP) in Algeria in 2009 to that in 2011?
Keep it short and to the point. 1.19. What is the ratio of the Domestic credit (% of GDP) in Small states in 2009 to that in 2012?
Your answer should be compact. 1.09. What is the ratio of the Domestic credit (% of GDP) of Sub-Saharan Africa (all income levels) in 2009 to that in 2012?
Your response must be concise. 1.36. What is the ratio of the Domestic credit (% of GDP) in Algeria in 2009 to that in 2012?
Offer a very short reply. 1.16. What is the ratio of the Domestic credit (% of GDP) of Small states in 2010 to that in 2011?
Offer a terse response. 1.04. What is the ratio of the Domestic credit (% of GDP) of Sub-Saharan Africa (all income levels) in 2010 to that in 2011?
Offer a very short reply. 1.06. What is the ratio of the Domestic credit (% of GDP) of Algeria in 2010 to that in 2011?
Provide a short and direct response. 1.11. What is the ratio of the Domestic credit (% of GDP) in Least developed countries in 2010 to that in 2012?
Keep it short and to the point. 1.03. What is the ratio of the Domestic credit (% of GDP) in Sub-Saharan Africa (all income levels) in 2010 to that in 2012?
Provide a short and direct response. 1.1. What is the ratio of the Domestic credit (% of GDP) of Algeria in 2010 to that in 2012?
Make the answer very short. 1.08. What is the ratio of the Domestic credit (% of GDP) of Least developed countries in 2011 to that in 2012?
Give a very brief answer. 1.03. What is the ratio of the Domestic credit (% of GDP) in Small states in 2011 to that in 2012?
Make the answer very short. 0.96. What is the ratio of the Domestic credit (% of GDP) of Sub-Saharan Africa (all income levels) in 2011 to that in 2012?
Make the answer very short. 1.04. What is the ratio of the Domestic credit (% of GDP) in Algeria in 2011 to that in 2012?
Make the answer very short. 0.98. What is the difference between the highest and the second highest Domestic credit (% of GDP) in Least developed countries?
Provide a short and direct response. 0.03. What is the difference between the highest and the second highest Domestic credit (% of GDP) in Small states?
Offer a very short reply. 3.01. What is the difference between the highest and the second highest Domestic credit (% of GDP) in Sub-Saharan Africa (all income levels)?
Your response must be concise. 1.58. What is the difference between the highest and the second highest Domestic credit (% of GDP) in Algeria?
Ensure brevity in your answer.  1.05. What is the difference between the highest and the lowest Domestic credit (% of GDP) of Least developed countries?
Your response must be concise. 6.27. What is the difference between the highest and the lowest Domestic credit (% of GDP) of Small states?
Provide a succinct answer. 4.6. What is the difference between the highest and the lowest Domestic credit (% of GDP) of Sub-Saharan Africa (all income levels)?
Make the answer very short. 11.08. What is the difference between the highest and the lowest Domestic credit (% of GDP) of Algeria?
Your answer should be very brief. 3.47. 